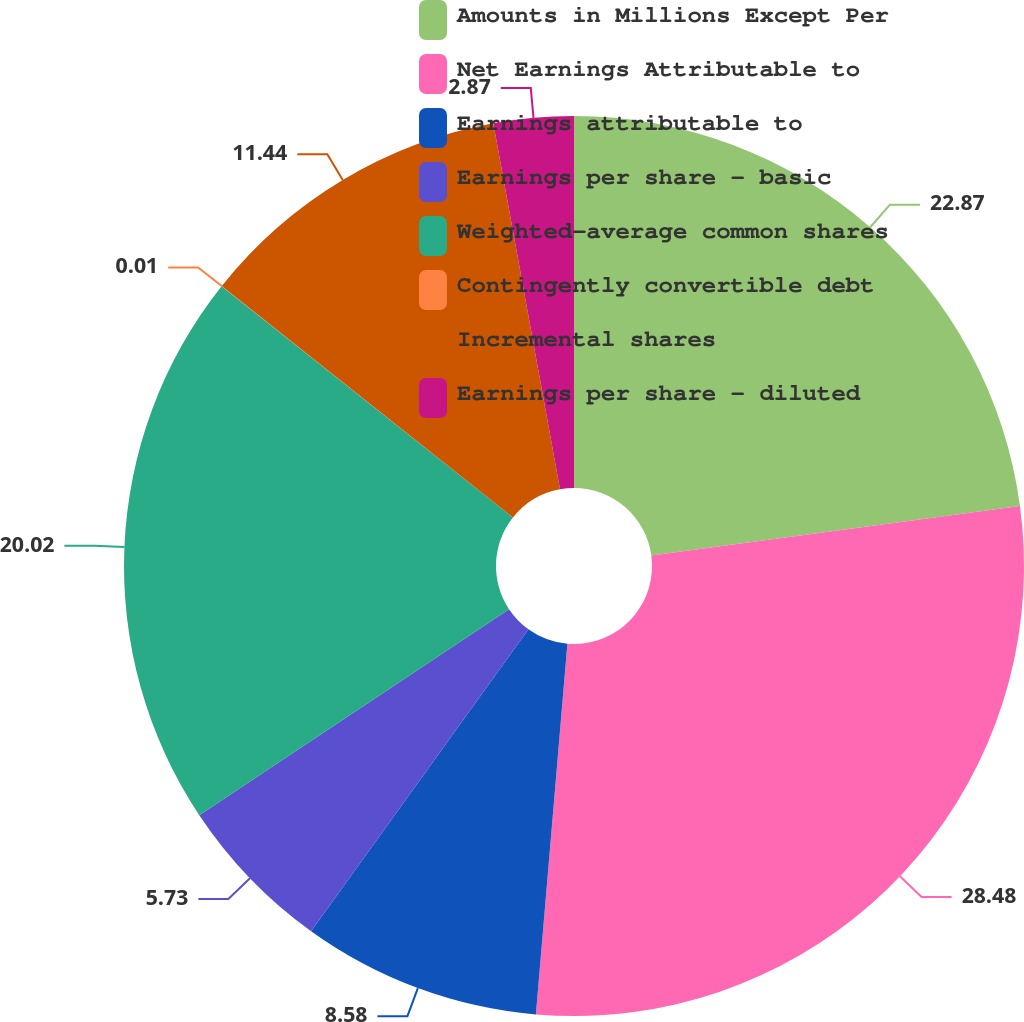Convert chart. <chart><loc_0><loc_0><loc_500><loc_500><pie_chart><fcel>Amounts in Millions Except Per<fcel>Net Earnings Attributable to<fcel>Earnings attributable to<fcel>Earnings per share - basic<fcel>Weighted-average common shares<fcel>Contingently convertible debt<fcel>Incremental shares<fcel>Earnings per share - diluted<nl><fcel>22.87%<fcel>28.48%<fcel>8.58%<fcel>5.73%<fcel>20.02%<fcel>0.01%<fcel>11.44%<fcel>2.87%<nl></chart> 